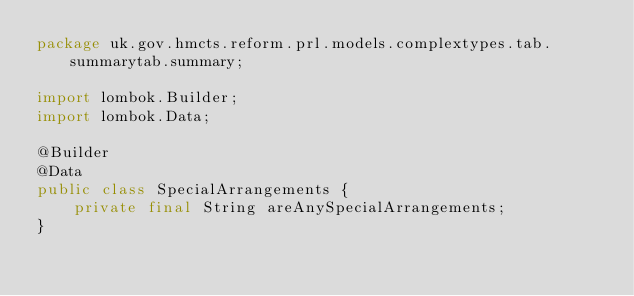Convert code to text. <code><loc_0><loc_0><loc_500><loc_500><_Java_>package uk.gov.hmcts.reform.prl.models.complextypes.tab.summarytab.summary;

import lombok.Builder;
import lombok.Data;

@Builder
@Data
public class SpecialArrangements {
    private final String areAnySpecialArrangements;
}
</code> 